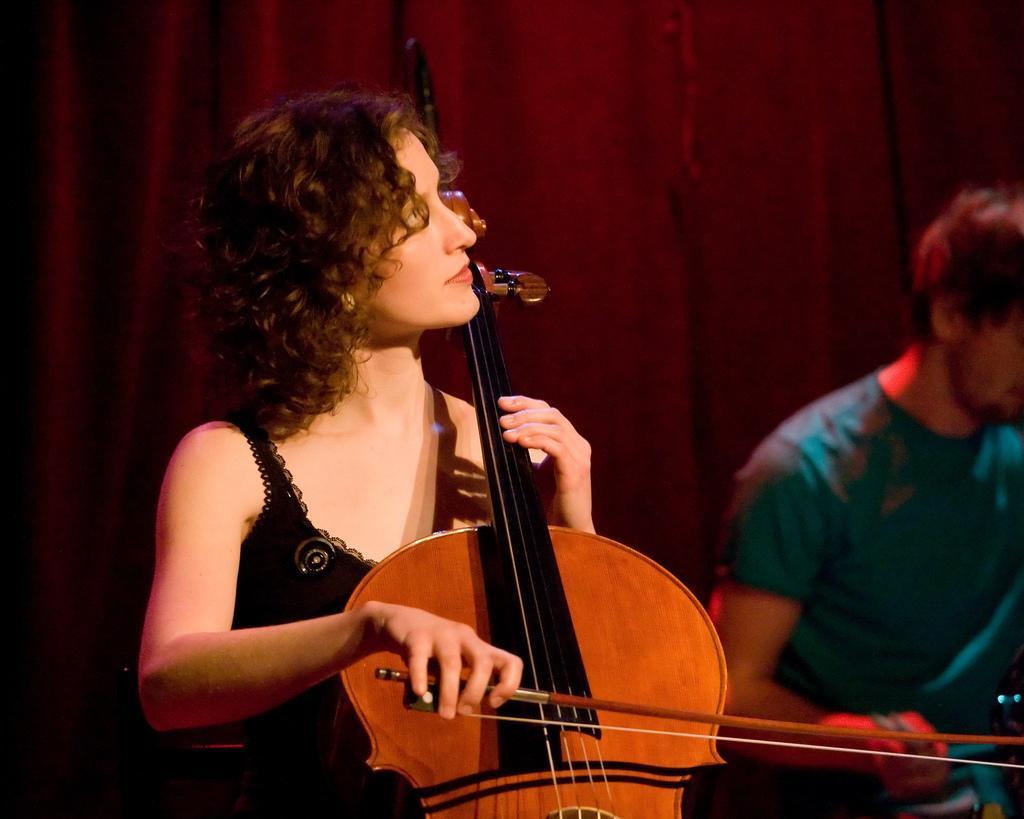Please provide a concise description of this image. The picture consists of two people, one woman in the left corner wearing black dress and playing violin and one man in blue t-shirt is sitting, behind them there is a red curtain. 